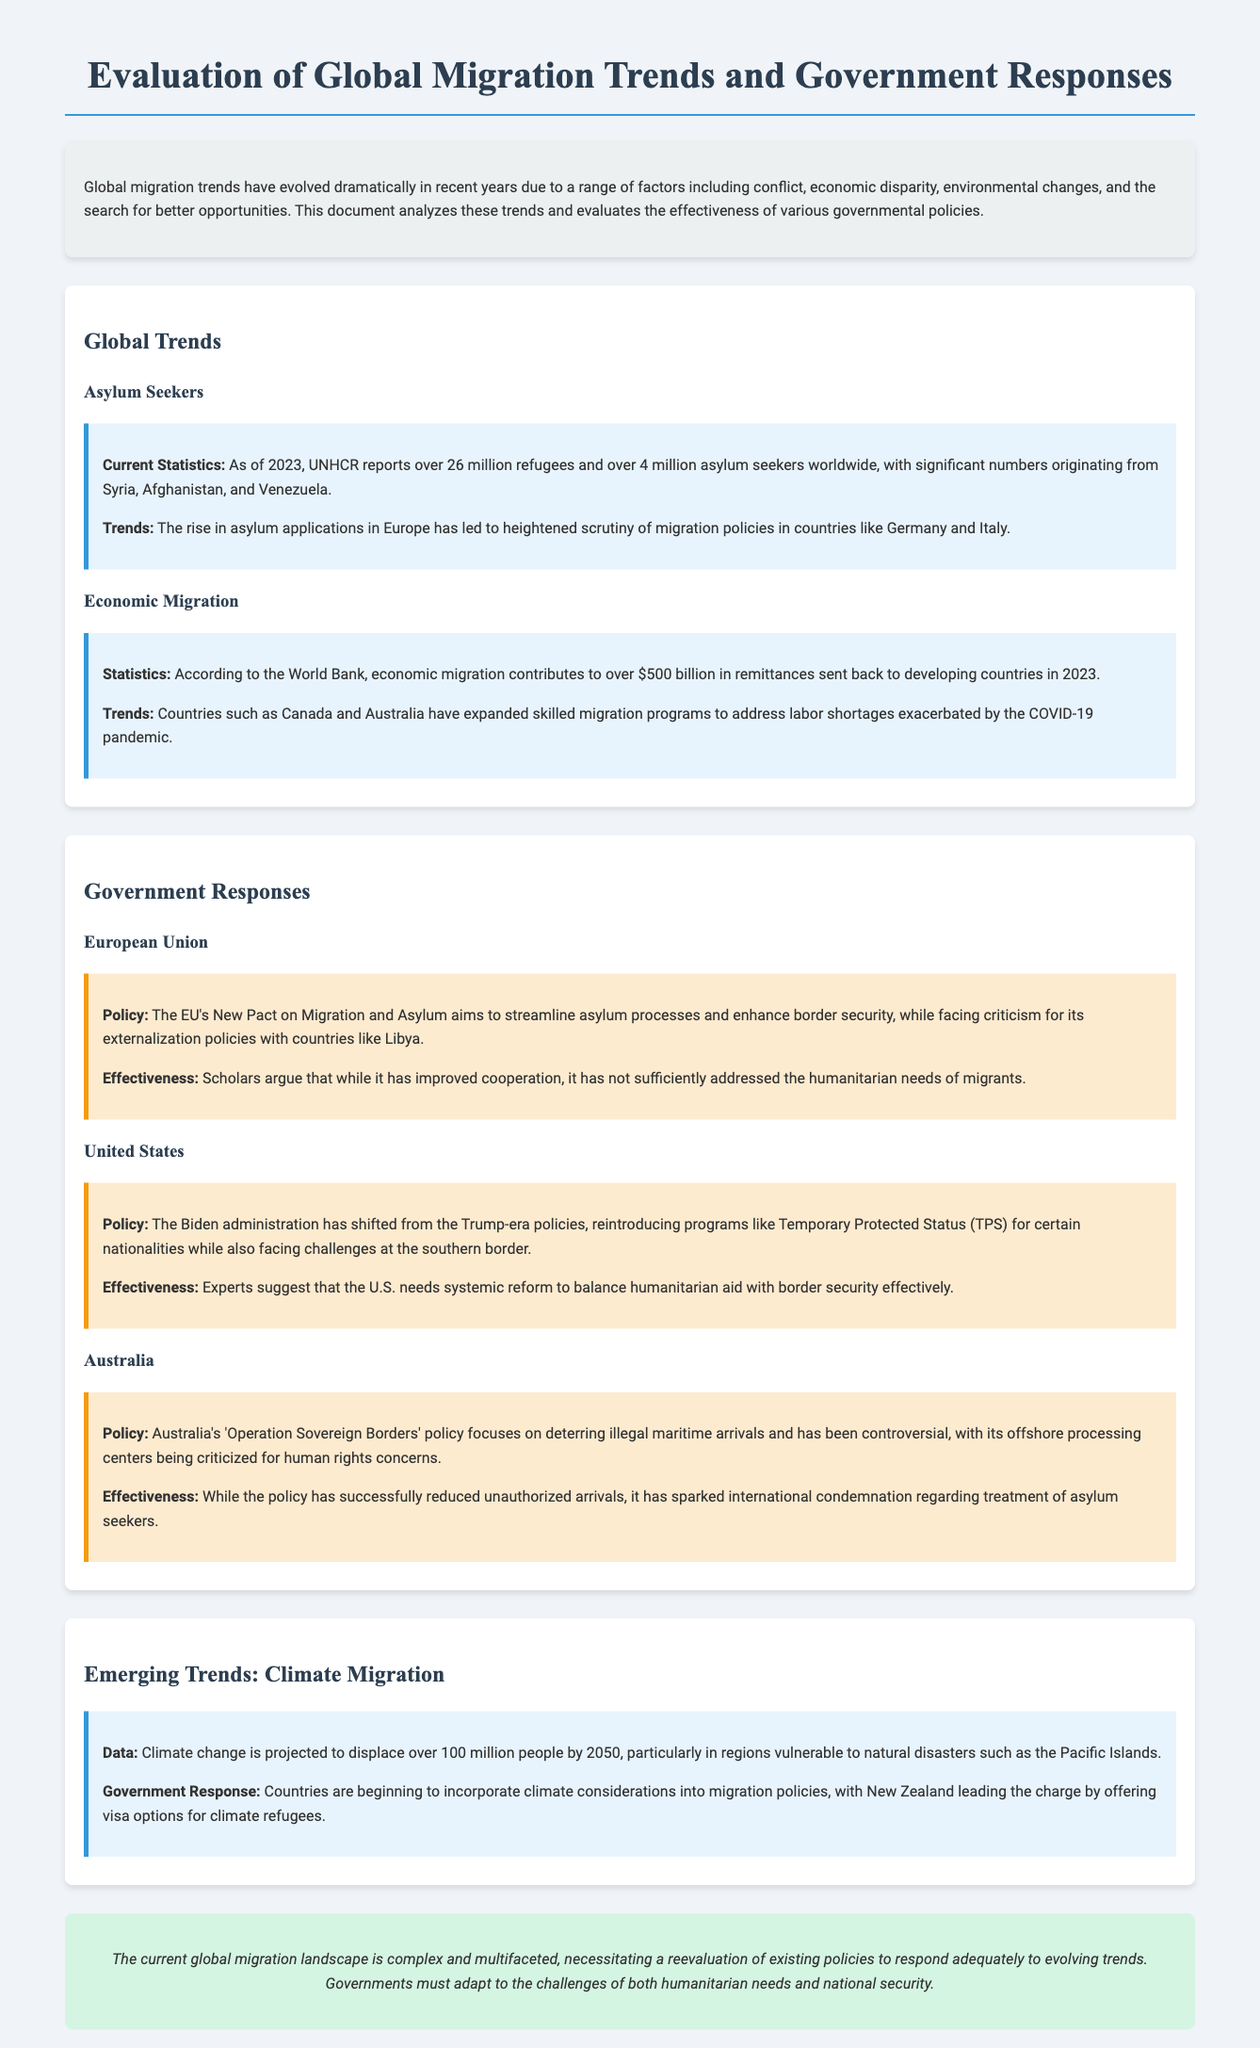What is the number of refugees reported by UNHCR? The UNHCR reports over 26 million refugees.
Answer: 26 million Which countries are significant sources of asylum seekers? The document mentions Syria, Afghanistan, and Venezuela as significant countries.
Answer: Syria, Afghanistan, Venezuela What is the contribution of economic migration in remittances? According to the World Bank, economic migration contributes to over $500 billion.
Answer: $500 billion What is the name of the policy the EU introduced for migration? The EU's policy is called the New Pact on Migration and Asylum.
Answer: New Pact on Migration and Asylum How many people are projected to be displaced due to climate change by 2050? The document states that climate change is projected to displace over 100 million people.
Answer: 100 million What program did the Biden administration reintroduce for certain nationalities? The reintroduced program is called Temporary Protected Status (TPS).
Answer: Temporary Protected Status (TPS) What is Australia's policy for handling illegal maritime arrivals? Australia's policy is known as Operation Sovereign Borders.
Answer: Operation Sovereign Borders What criticisms does the EU face regarding its migration policy? The EU faces criticism for its externalization policies with countries like Libya.
Answer: Externalization policies with countries like Libya What should governments adapt to according to the conclusion? Governments must adapt to the challenges of humanitarian needs and national security.
Answer: Humanitarian needs and national security 